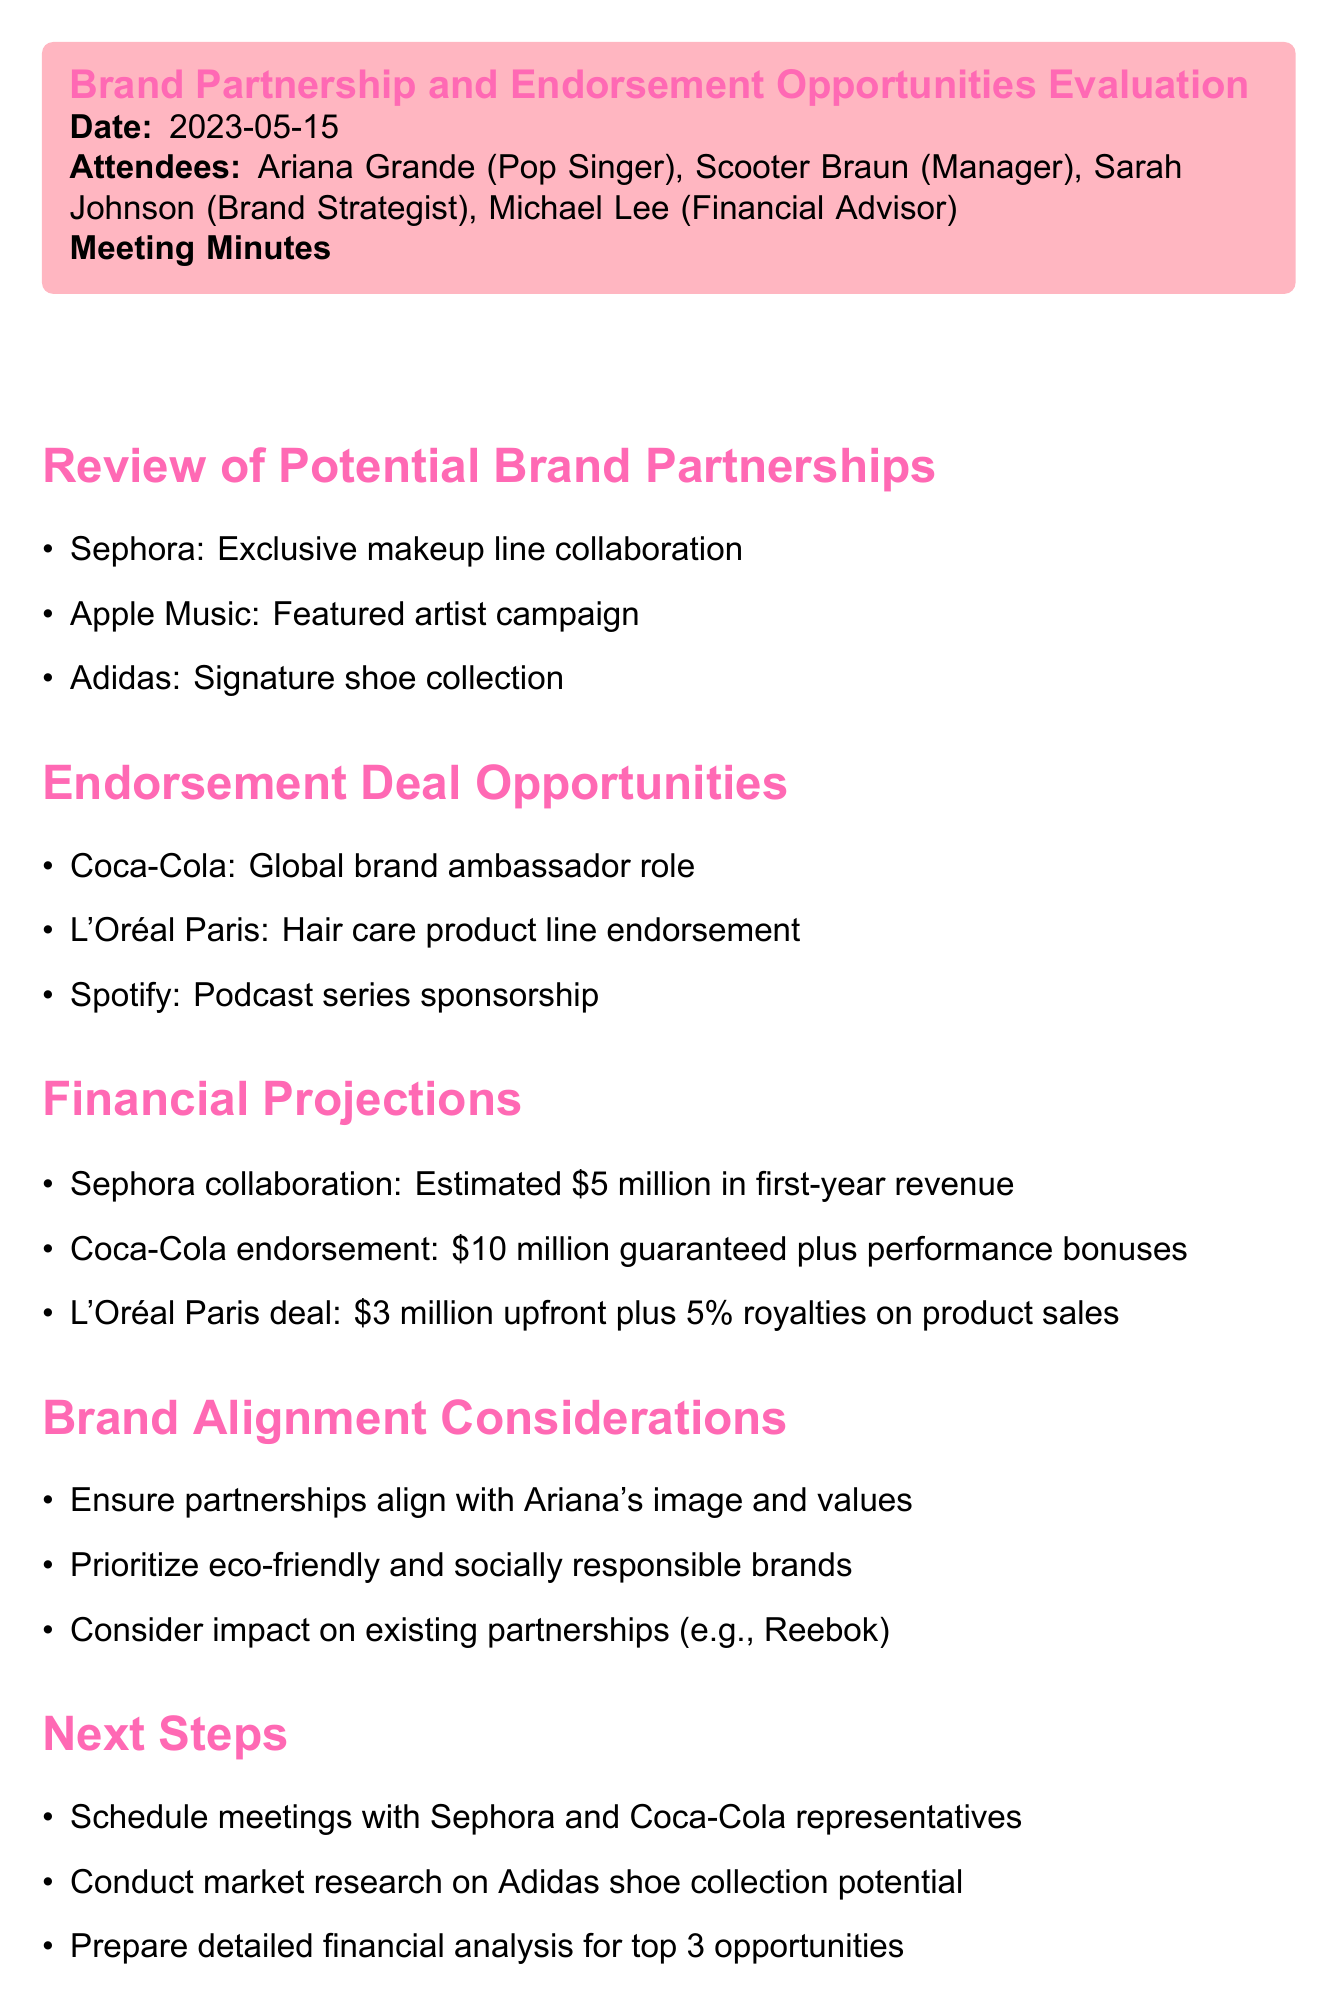What is the date of the meeting? The date of the meeting is explicitly stated in the document under the meeting header.
Answer: 2023-05-15 Who is the brand strategist that attended the meeting? The attendees section lists the names of the participants, including their roles.
Answer: Sarah Johnson What is the estimated revenue from the Sephora collaboration? The financial projections section provides the estimated revenue from each mentioned opportunity.
Answer: $5 million Which company is associated with the global brand ambassador role? The endorsement deal opportunities list includes specific companies and their associated roles.
Answer: Coca-Cola What percentage of royalties does L'Oréal Paris deal offer? The financial projections related to the L'Oréal Paris deal include a percentage of royalties.
Answer: 5% What should be prioritized according to the brand alignment considerations? The brand alignment considerations highlight specific values and priorities for partnerships.
Answer: Eco-friendly and socially responsible brands What are the next steps regarding the Adidas shoe collection? The next steps outline actions to be taken after the meeting.
Answer: Conduct market research How many endorsement deals were discussed? The endorsement deal opportunities section enumerates the deals being considered.
Answer: Three Which artist is the focus of the featured artist campaign by Apple Music? The review of potential brand partnerships mentions the campaign associated with Apple Music.
Answer: Ariana Grande 